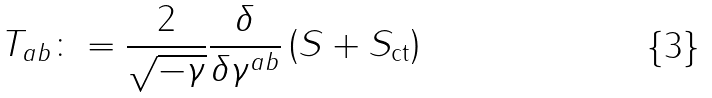<formula> <loc_0><loc_0><loc_500><loc_500>T _ { a b } \colon = \frac { 2 } { \sqrt { - \gamma } } \frac { \delta } { \delta \gamma ^ { a b } } \left ( S + S _ { \text {ct} } \right )</formula> 